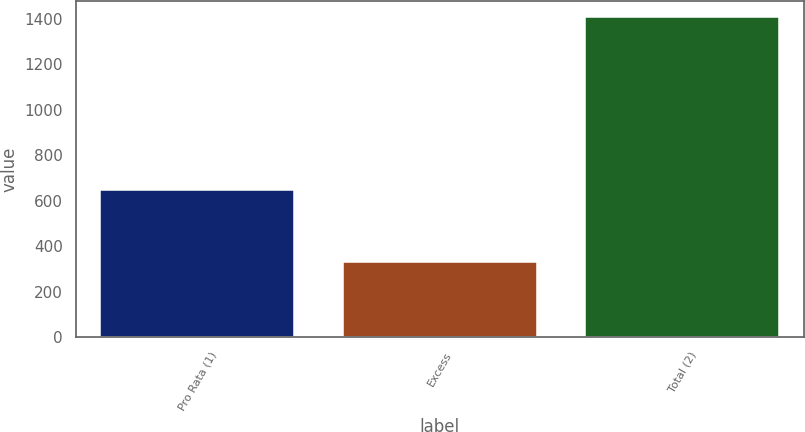Convert chart to OTSL. <chart><loc_0><loc_0><loc_500><loc_500><bar_chart><fcel>Pro Rata (1)<fcel>Excess<fcel>Total (2)<nl><fcel>648.2<fcel>330.5<fcel>1407.1<nl></chart> 